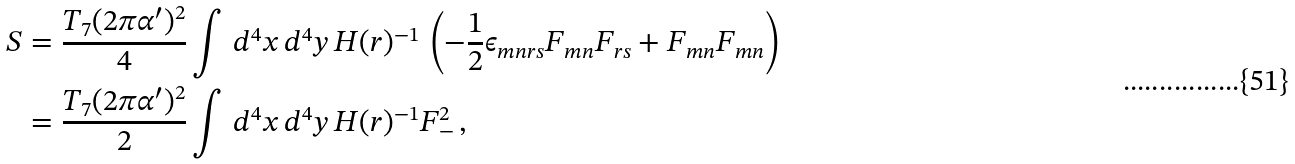<formula> <loc_0><loc_0><loc_500><loc_500>S & = \frac { T _ { 7 } ( 2 \pi \alpha ^ { \prime } ) ^ { 2 } } { 4 } \int \, d ^ { 4 } x \, d ^ { 4 } y \, H ( r ) ^ { - 1 } \, \left ( - \frac { 1 } { 2 } \epsilon _ { m n r s } F _ { m n } F _ { r s } + F _ { m n } F _ { m n } \right ) \\ & = \frac { T _ { 7 } ( 2 \pi \alpha ^ { \prime } ) ^ { 2 } } { 2 } \int \, d ^ { 4 } x \, d ^ { 4 } y \, H ( r ) ^ { - 1 } F _ { - } ^ { 2 } \, ,</formula> 